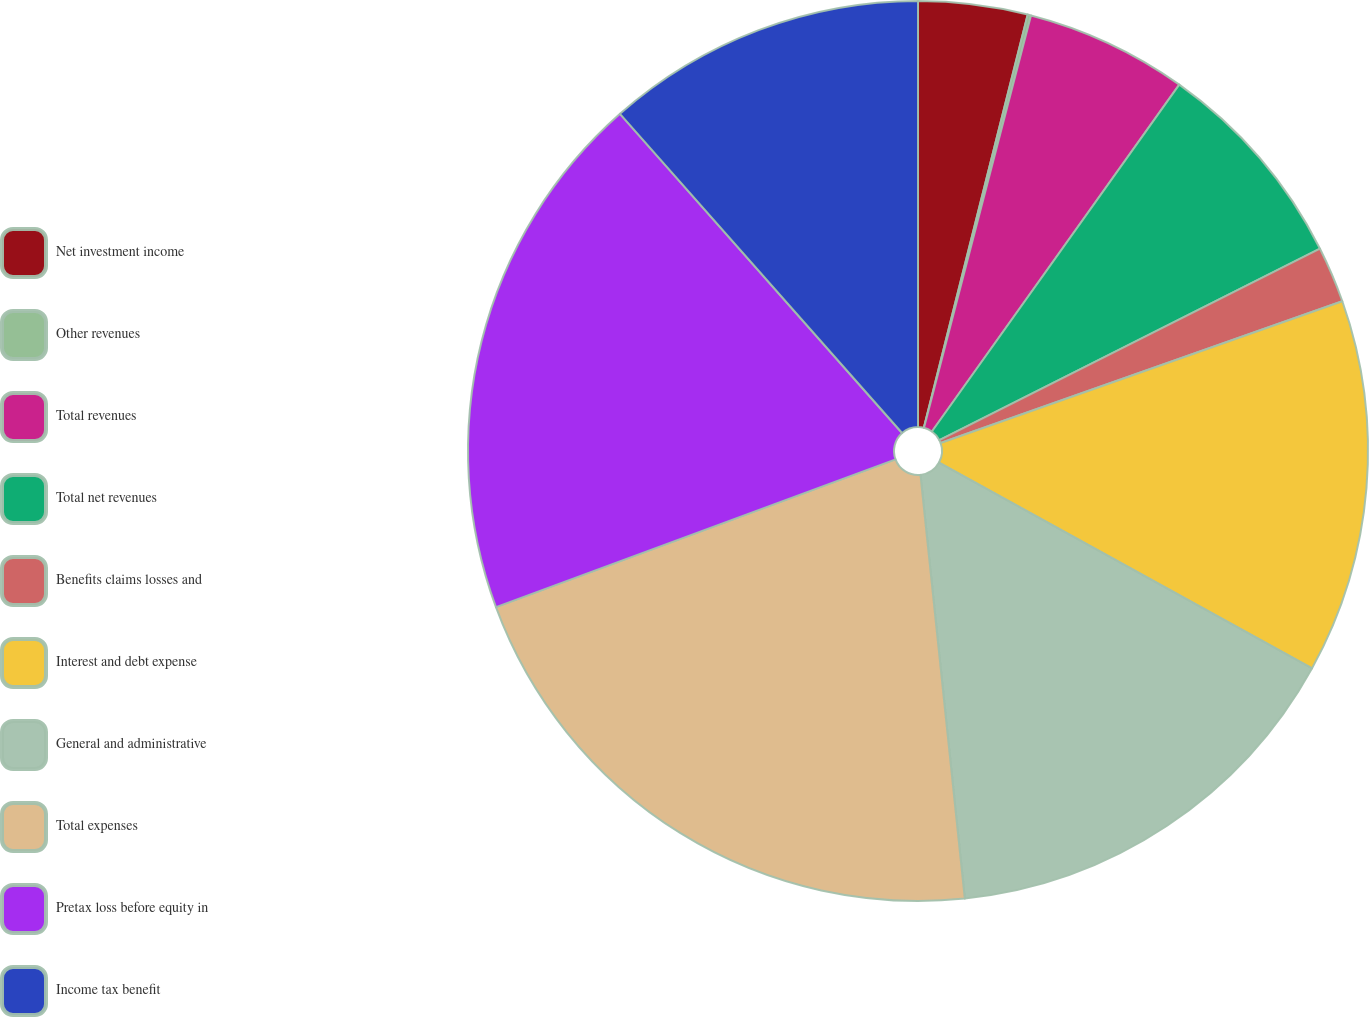Convert chart to OTSL. <chart><loc_0><loc_0><loc_500><loc_500><pie_chart><fcel>Net investment income<fcel>Other revenues<fcel>Total revenues<fcel>Total net revenues<fcel>Benefits claims losses and<fcel>Interest and debt expense<fcel>General and administrative<fcel>Total expenses<fcel>Pretax loss before equity in<fcel>Income tax benefit<nl><fcel>3.92%<fcel>0.12%<fcel>5.82%<fcel>7.72%<fcel>2.02%<fcel>13.42%<fcel>15.32%<fcel>21.02%<fcel>19.12%<fcel>11.52%<nl></chart> 